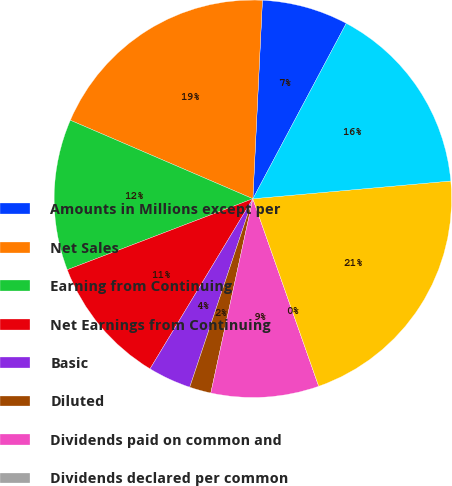Convert chart to OTSL. <chart><loc_0><loc_0><loc_500><loc_500><pie_chart><fcel>Amounts in Millions except per<fcel>Net Sales<fcel>Earning from Continuing<fcel>Net Earnings from Continuing<fcel>Basic<fcel>Diluted<fcel>Dividends paid on common and<fcel>Dividends declared per common<fcel>Total Assets<fcel>Cash and cash equivalents<nl><fcel>7.02%<fcel>19.3%<fcel>12.28%<fcel>10.53%<fcel>3.51%<fcel>1.75%<fcel>8.77%<fcel>0.0%<fcel>21.05%<fcel>15.79%<nl></chart> 